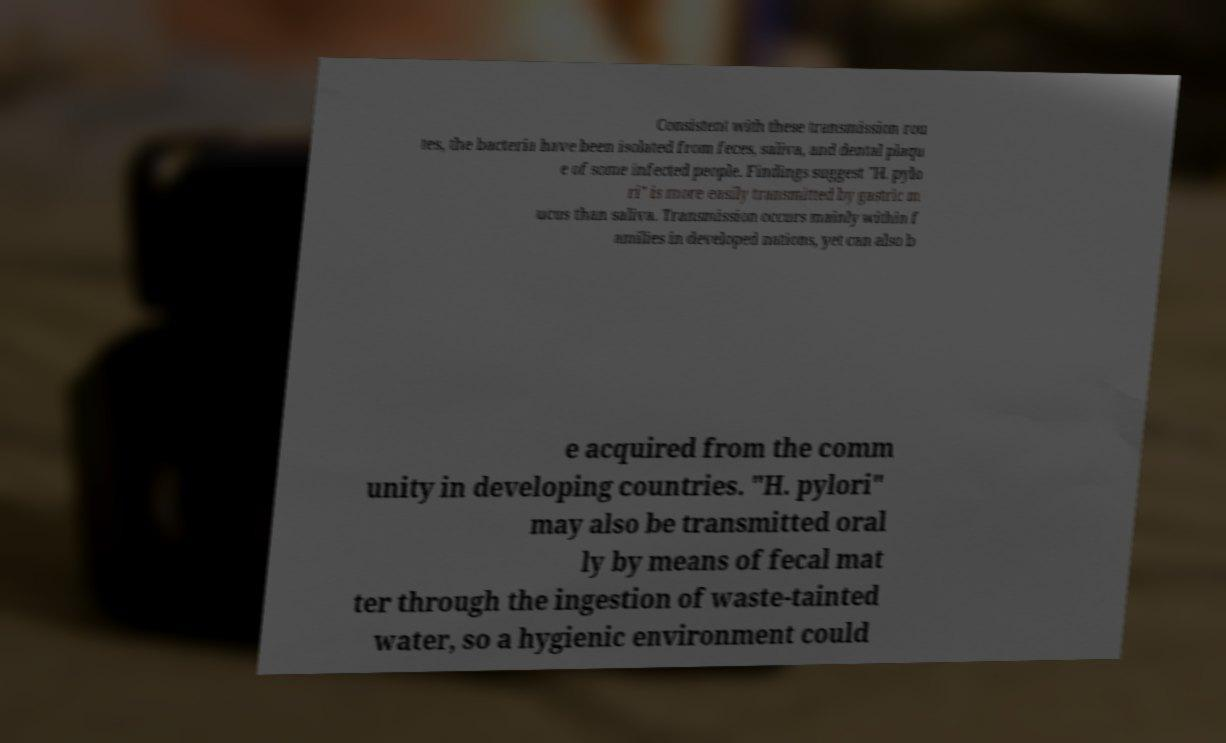Could you extract and type out the text from this image? Consistent with these transmission rou tes, the bacteria have been isolated from feces, saliva, and dental plaqu e of some infected people. Findings suggest "H. pylo ri" is more easily transmitted by gastric m ucus than saliva. Transmission occurs mainly within f amilies in developed nations, yet can also b e acquired from the comm unity in developing countries. "H. pylori" may also be transmitted oral ly by means of fecal mat ter through the ingestion of waste-tainted water, so a hygienic environment could 